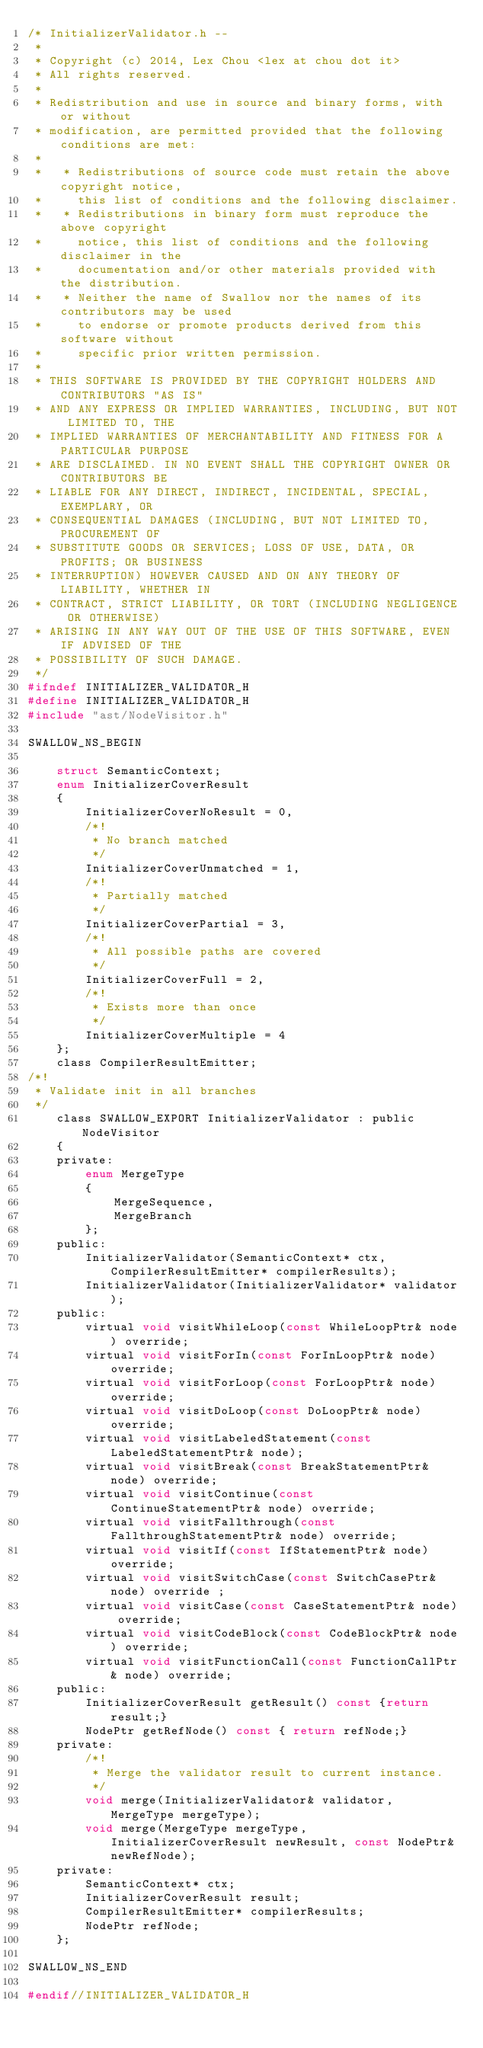Convert code to text. <code><loc_0><loc_0><loc_500><loc_500><_C_>/* InitializerValidator.h --
 *
 * Copyright (c) 2014, Lex Chou <lex at chou dot it>
 * All rights reserved.
 *
 * Redistribution and use in source and binary forms, with or without
 * modification, are permitted provided that the following conditions are met:
 *
 *   * Redistributions of source code must retain the above copyright notice,
 *     this list of conditions and the following disclaimer.
 *   * Redistributions in binary form must reproduce the above copyright
 *     notice, this list of conditions and the following disclaimer in the
 *     documentation and/or other materials provided with the distribution.
 *   * Neither the name of Swallow nor the names of its contributors may be used
 *     to endorse or promote products derived from this software without
 *     specific prior written permission.
 *
 * THIS SOFTWARE IS PROVIDED BY THE COPYRIGHT HOLDERS AND CONTRIBUTORS "AS IS"
 * AND ANY EXPRESS OR IMPLIED WARRANTIES, INCLUDING, BUT NOT LIMITED TO, THE
 * IMPLIED WARRANTIES OF MERCHANTABILITY AND FITNESS FOR A PARTICULAR PURPOSE
 * ARE DISCLAIMED. IN NO EVENT SHALL THE COPYRIGHT OWNER OR CONTRIBUTORS BE
 * LIABLE FOR ANY DIRECT, INDIRECT, INCIDENTAL, SPECIAL, EXEMPLARY, OR
 * CONSEQUENTIAL DAMAGES (INCLUDING, BUT NOT LIMITED TO, PROCUREMENT OF
 * SUBSTITUTE GOODS OR SERVICES; LOSS OF USE, DATA, OR PROFITS; OR BUSINESS
 * INTERRUPTION) HOWEVER CAUSED AND ON ANY THEORY OF LIABILITY, WHETHER IN
 * CONTRACT, STRICT LIABILITY, OR TORT (INCLUDING NEGLIGENCE OR OTHERWISE)
 * ARISING IN ANY WAY OUT OF THE USE OF THIS SOFTWARE, EVEN IF ADVISED OF THE
 * POSSIBILITY OF SUCH DAMAGE.
 */
#ifndef INITIALIZER_VALIDATOR_H
#define INITIALIZER_VALIDATOR_H
#include "ast/NodeVisitor.h"

SWALLOW_NS_BEGIN

    struct SemanticContext;
    enum InitializerCoverResult
    {
        InitializerCoverNoResult = 0,
        /*!
         * No branch matched
         */
        InitializerCoverUnmatched = 1,
        /*!
         * Partially matched
         */
        InitializerCoverPartial = 3,
        /*!
         * All possible paths are covered
         */
        InitializerCoverFull = 2,
        /*!
         * Exists more than once
         */
        InitializerCoverMultiple = 4
    };
    class CompilerResultEmitter;
/*!
 * Validate init in all branches
 */
    class SWALLOW_EXPORT InitializerValidator : public NodeVisitor
    {
    private:
        enum MergeType
        {
            MergeSequence,
            MergeBranch
        };
    public:
        InitializerValidator(SemanticContext* ctx, CompilerResultEmitter* compilerResults);
        InitializerValidator(InitializerValidator* validator);
    public:
        virtual void visitWhileLoop(const WhileLoopPtr& node) override;
        virtual void visitForIn(const ForInLoopPtr& node) override;
        virtual void visitForLoop(const ForLoopPtr& node) override;
        virtual void visitDoLoop(const DoLoopPtr& node) override;
        virtual void visitLabeledStatement(const LabeledStatementPtr& node);
        virtual void visitBreak(const BreakStatementPtr& node) override;
        virtual void visitContinue(const ContinueStatementPtr& node) override;
        virtual void visitFallthrough(const FallthroughStatementPtr& node) override;
        virtual void visitIf(const IfStatementPtr& node) override;
        virtual void visitSwitchCase(const SwitchCasePtr& node) override ;
        virtual void visitCase(const CaseStatementPtr& node) override;
        virtual void visitCodeBlock(const CodeBlockPtr& node) override;
        virtual void visitFunctionCall(const FunctionCallPtr& node) override;
    public:
        InitializerCoverResult getResult() const {return result;}
        NodePtr getRefNode() const { return refNode;}
    private:
        /*!
         * Merge the validator result to current instance.
         */
        void merge(InitializerValidator& validator, MergeType mergeType);
        void merge(MergeType mergeType, InitializerCoverResult newResult, const NodePtr& newRefNode);
    private:
        SemanticContext* ctx;
        InitializerCoverResult result;
        CompilerResultEmitter* compilerResults;
        NodePtr refNode;
    };

SWALLOW_NS_END

#endif//INITIALIZER_VALIDATOR_H
</code> 